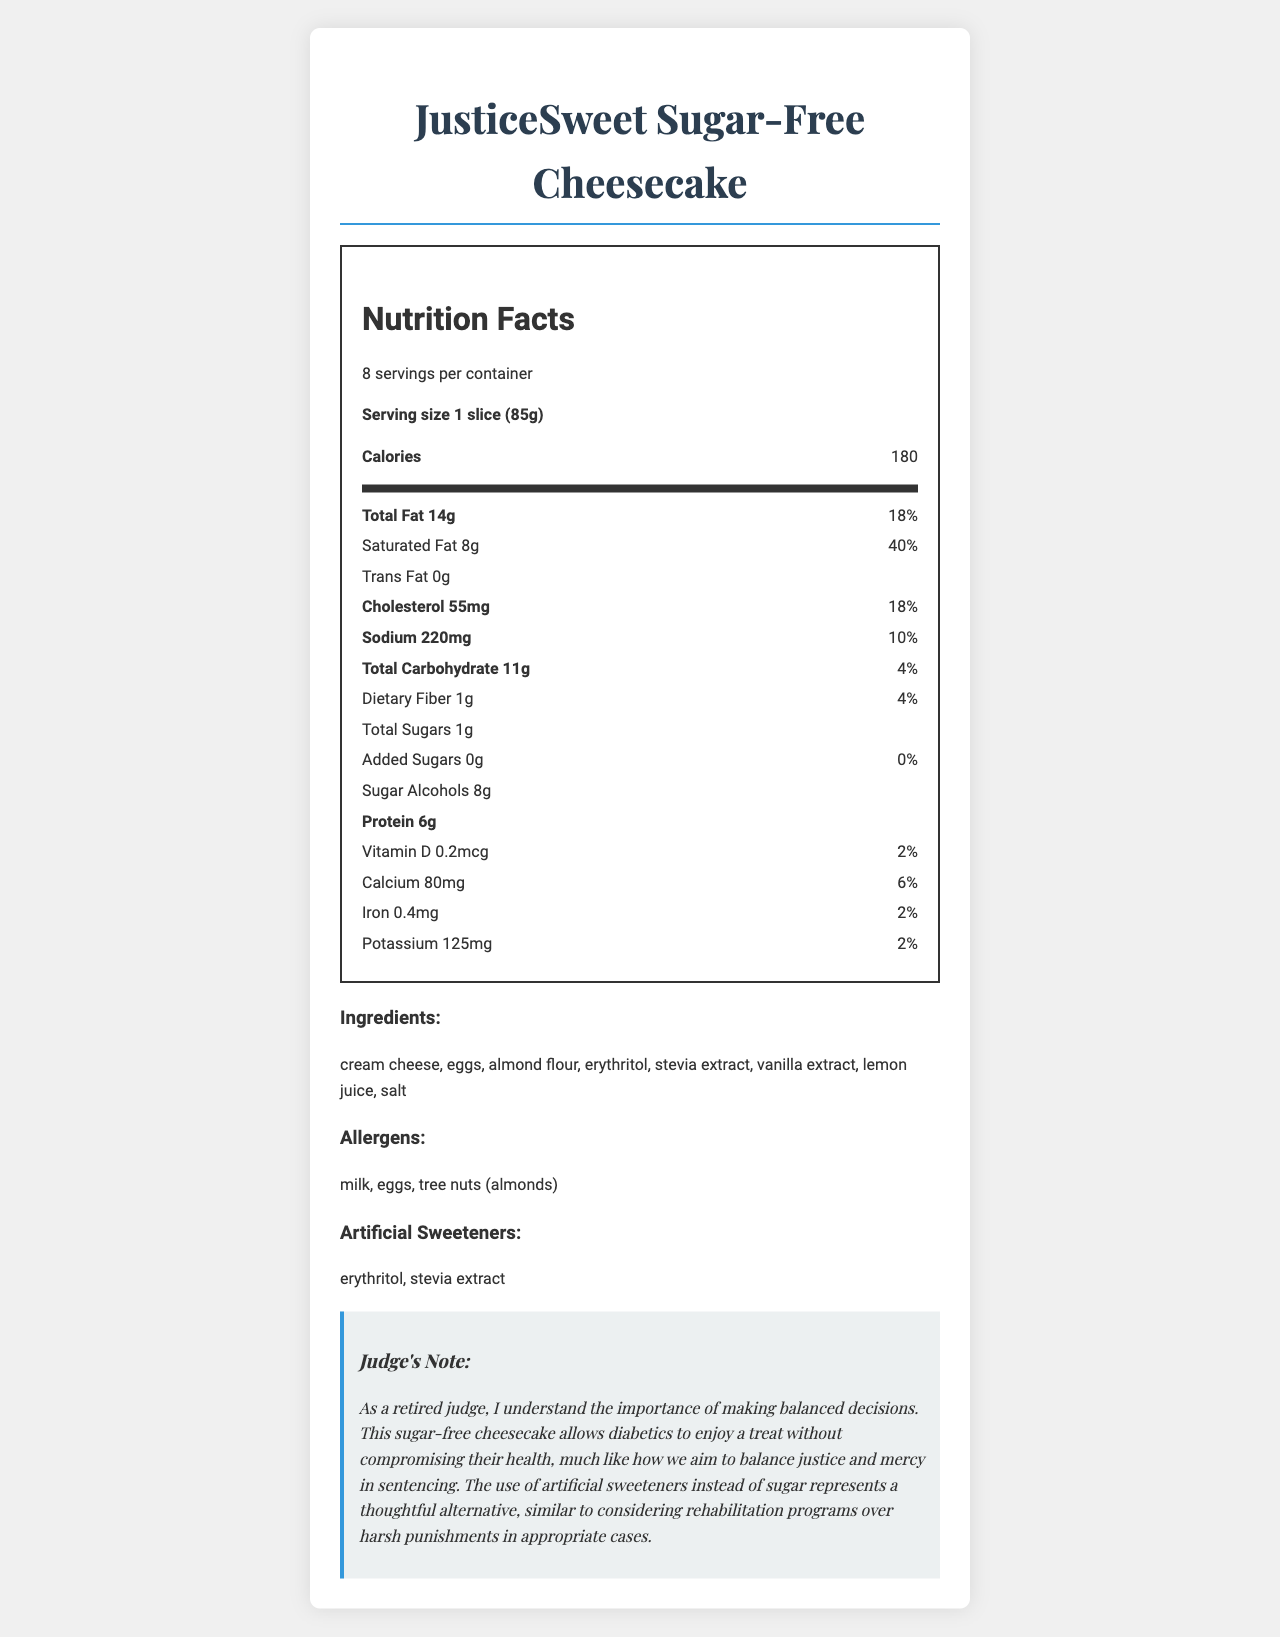what is the serving size for JusticeSweet Sugar-Free Cheesecake? The serving size is clearly listed at the top of the Nutrition Facts section.
Answer: 1 slice (85g) how many servings per container does the cheesecake have? The document states there are 8 servings per container underneath the product name.
Answer: 8 what is the total fat content per serving? Under the Nutrition Facts section, it mentions "Total Fat 14g."
Answer: 14g what are the two artificial sweeteners used in this cheesecake? The section titled "Artificial Sweeteners" lists erythritol and stevia extract.
Answer: erythritol, stevia extract how much sodium is in one serving? The sodium content is listed as 220mg under the Nutrition Facts.
Answer: 220mg what is the percentage of Daily Value for saturated fat per serving? The document lists the daily value of saturated fat as 40%.
Answer: 40% which nutrient has the highest percentage of daily value? A. Total Fat B. Saturated Fat C. Sodium D. Total Carbohydrates Saturated Fat has the highest daily value at 40%, compared to the other options.
Answer: B. Saturated Fat how much dietary fiber does one serving contain? A. 0g B. 1g C. 2g D. 3g The nutritional label lists dietary fiber as 1g.
Answer: B. 1g are there any added sugars in the cheesecake? The Nutrition Facts list the amount of added sugars as 0g.
Answer: No does the dessert contain any allergens? According to the allergens section, it contains milk, eggs, and tree nuts (almonds).
Answer: Yes summarize the main nutritional characteristics of the JusticeSweet Sugar-Free Cheesecake. The summary includes an overview of the calorie content, fats, sugars, artificial sweeteners, and allergens, emphasizing its suitability for diabetics.
Answer: The JusticeSweet Sugar-Free Cheesecake is a diabetic-friendly dessert with 180 calories per serving. It contains 14g of total fat with 8g of saturated fat. It has minimal sugars (1g) but 8g of sugar alcohols and includes artificial sweeteners like erythritol and stevia extract. It is a good source of protein (6g) and contains common allergens like milk, eggs, and almonds. The dessert balances reduced sugar content with a higher fat and moderate protein profile suitable for diabetics. what is the judge's note about this cheesecake? The Judge's Note comments on the dessert's health benefits for diabetics and draws an analogy to the balanced decisions in the justice system.
Answer: The judge notes that the sugar-free cheesecake allows diabetics to enjoy a treat without compromising their health, similar to how balanced justice decisions consider rehabilitation. why was stevia extract mentioned in the document? The section "Artificial Sweeteners" lists stevia extract as one of the artificial sweeteners used in the cheesecake.
Answer: As an artificial sweetener what is the total amount of calcium in one serving of the cheesecake? The calcium amount per serving is listed as 80mg in the Nutrition Facts section.
Answer: 80mg what is the source of protein in the cheesecake? The document does not specify the sources of protein, only the amount per serving.
Answer: Cannot be determined 